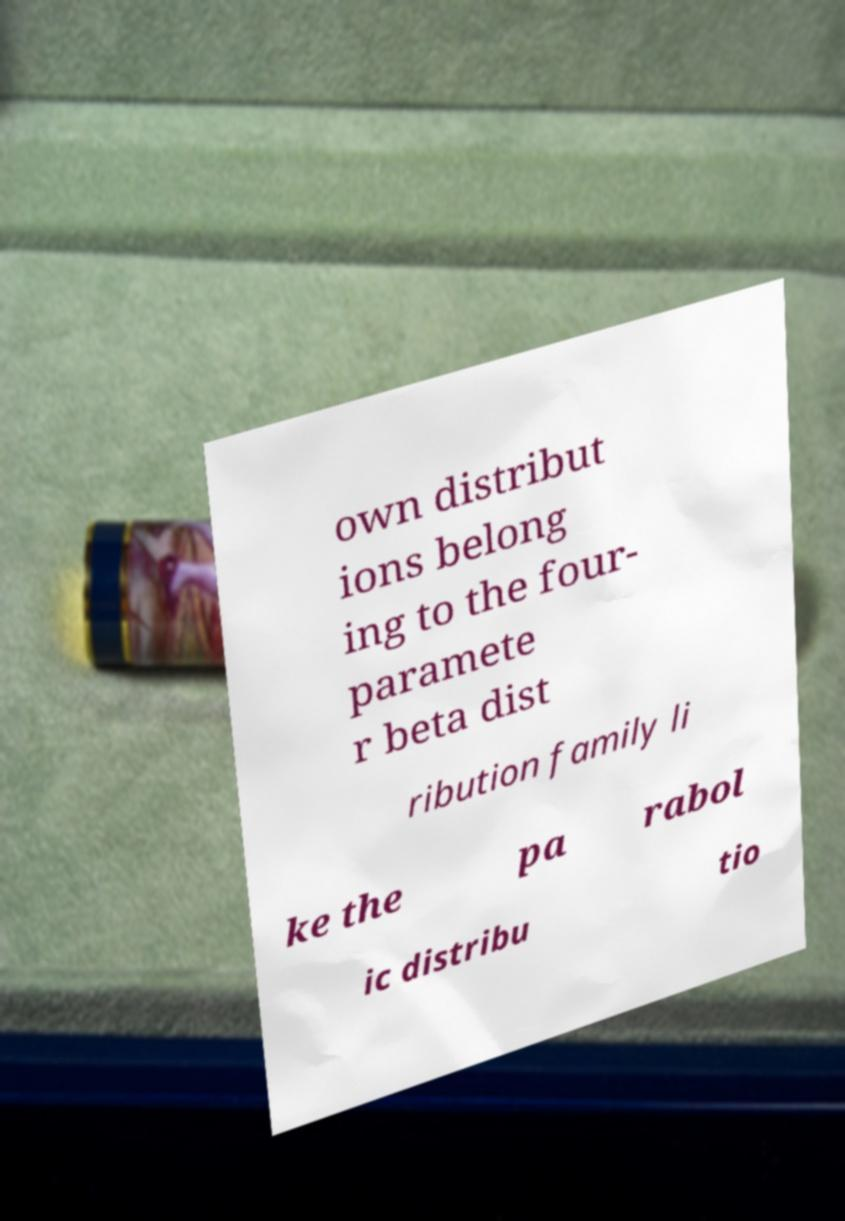For documentation purposes, I need the text within this image transcribed. Could you provide that? own distribut ions belong ing to the four- paramete r beta dist ribution family li ke the pa rabol ic distribu tio 